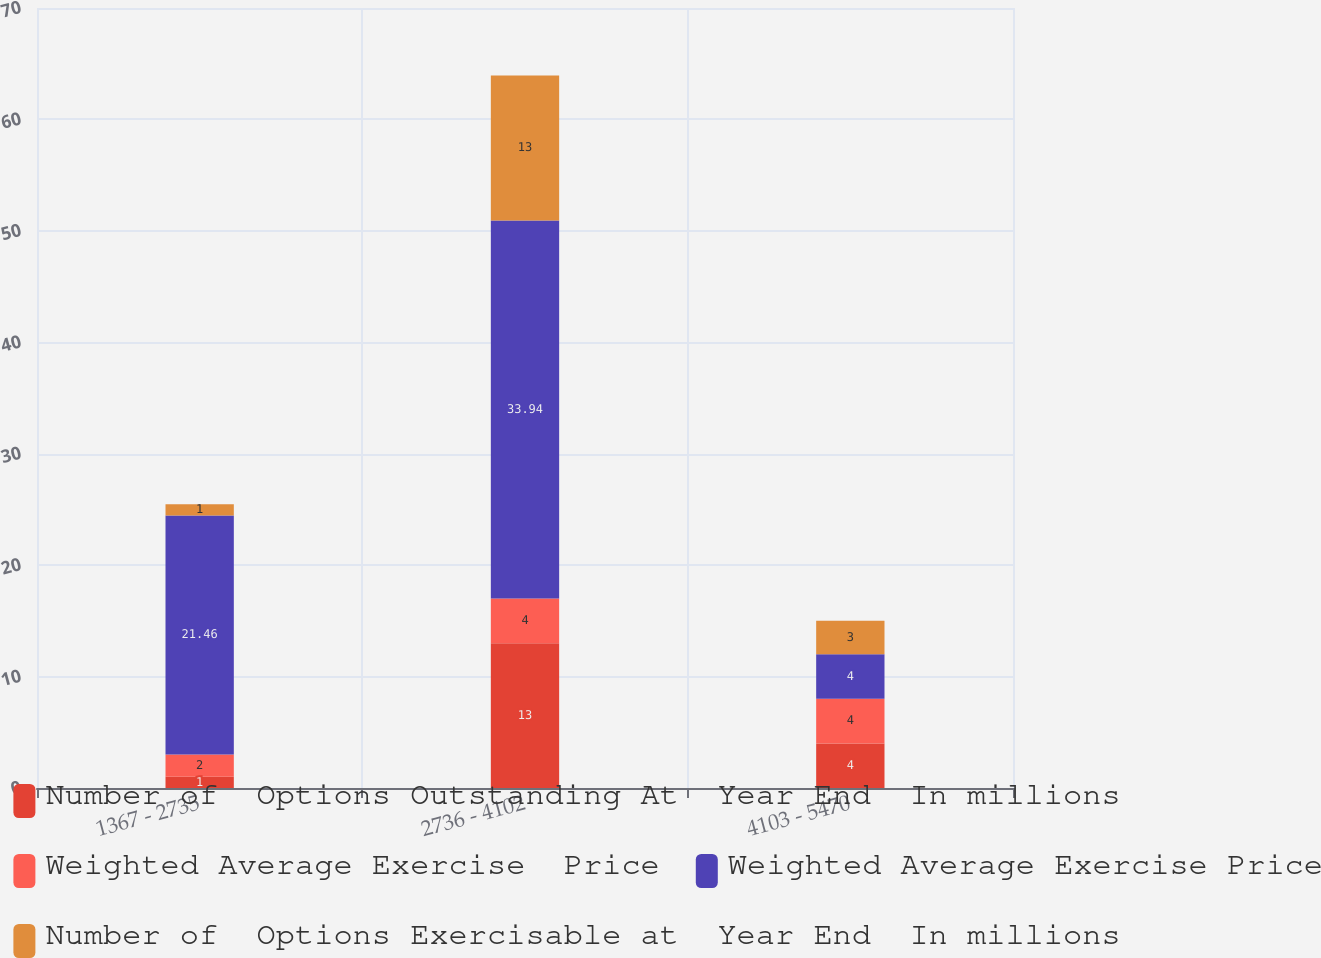Convert chart to OTSL. <chart><loc_0><loc_0><loc_500><loc_500><stacked_bar_chart><ecel><fcel>1367 - 2735<fcel>2736 - 4102<fcel>4103 - 5470<nl><fcel>Number of  Options Outstanding At  Year End  In millions<fcel>1<fcel>13<fcel>4<nl><fcel>Weighted Average Exercise  Price<fcel>2<fcel>4<fcel>4<nl><fcel>Weighted Average Exercise Price<fcel>21.46<fcel>33.94<fcel>4<nl><fcel>Number of  Options Exercisable at  Year End  In millions<fcel>1<fcel>13<fcel>3<nl></chart> 